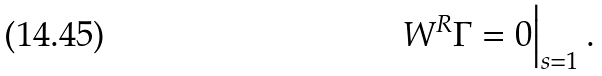Convert formula to latex. <formula><loc_0><loc_0><loc_500><loc_500>W ^ { R } \Gamma = 0 \Big | _ { s = 1 } \, .</formula> 